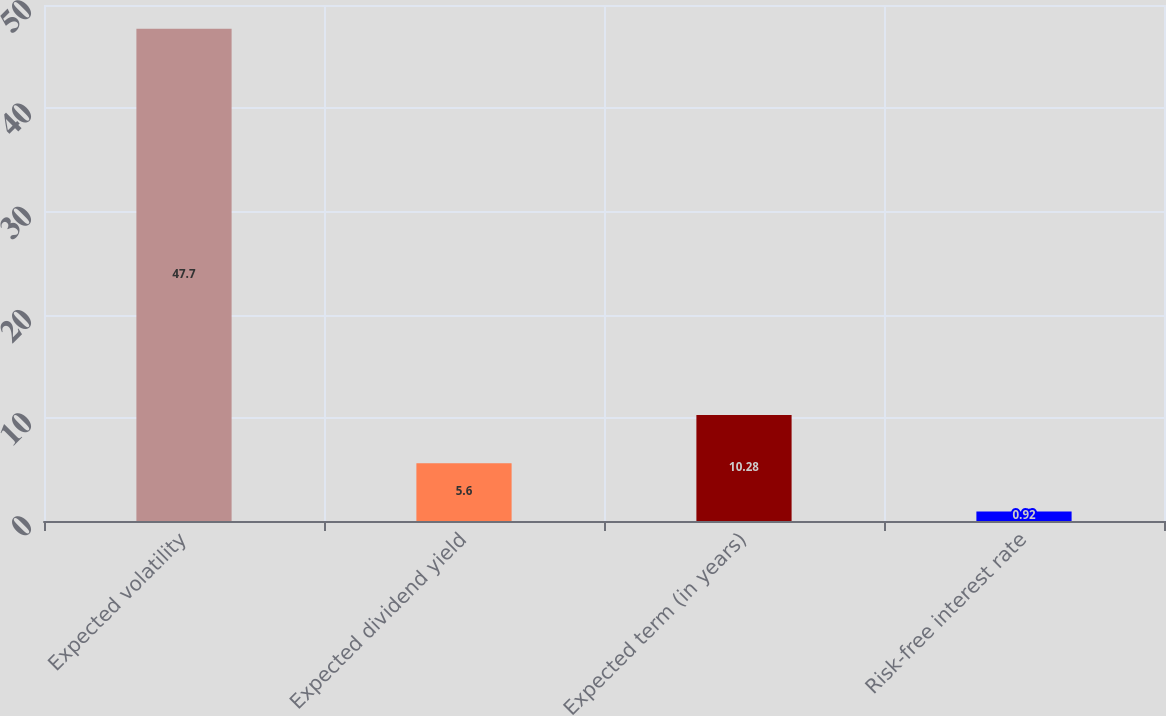Convert chart to OTSL. <chart><loc_0><loc_0><loc_500><loc_500><bar_chart><fcel>Expected volatility<fcel>Expected dividend yield<fcel>Expected term (in years)<fcel>Risk-free interest rate<nl><fcel>47.7<fcel>5.6<fcel>10.28<fcel>0.92<nl></chart> 